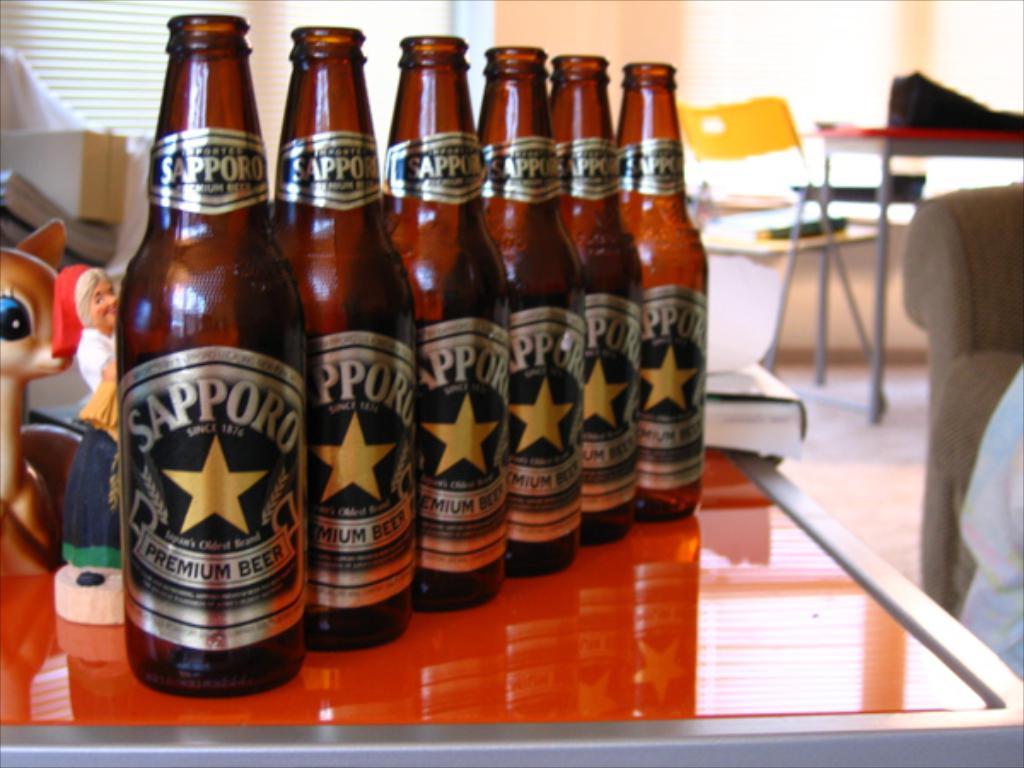What drinks are those?
Make the answer very short. Sapporo premium beer. What brand are these?
Provide a short and direct response. Sapporo. 